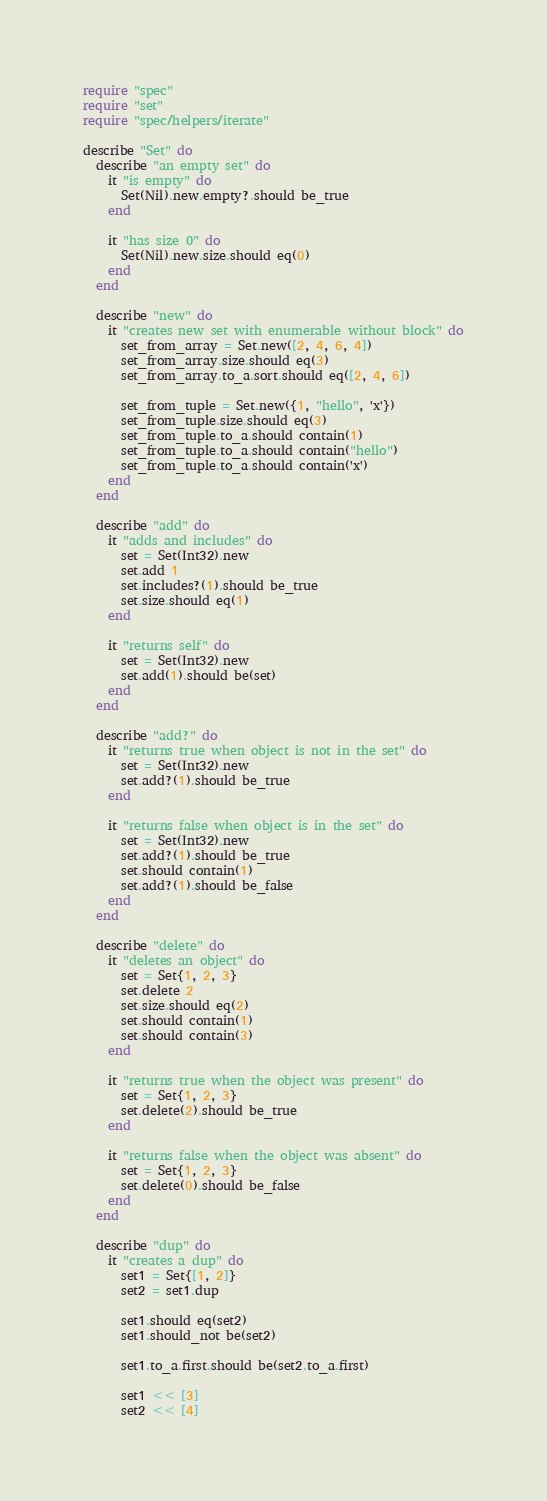Convert code to text. <code><loc_0><loc_0><loc_500><loc_500><_Crystal_>require "spec"
require "set"
require "spec/helpers/iterate"

describe "Set" do
  describe "an empty set" do
    it "is empty" do
      Set(Nil).new.empty?.should be_true
    end

    it "has size 0" do
      Set(Nil).new.size.should eq(0)
    end
  end

  describe "new" do
    it "creates new set with enumerable without block" do
      set_from_array = Set.new([2, 4, 6, 4])
      set_from_array.size.should eq(3)
      set_from_array.to_a.sort.should eq([2, 4, 6])

      set_from_tuple = Set.new({1, "hello", 'x'})
      set_from_tuple.size.should eq(3)
      set_from_tuple.to_a.should contain(1)
      set_from_tuple.to_a.should contain("hello")
      set_from_tuple.to_a.should contain('x')
    end
  end

  describe "add" do
    it "adds and includes" do
      set = Set(Int32).new
      set.add 1
      set.includes?(1).should be_true
      set.size.should eq(1)
    end

    it "returns self" do
      set = Set(Int32).new
      set.add(1).should be(set)
    end
  end

  describe "add?" do
    it "returns true when object is not in the set" do
      set = Set(Int32).new
      set.add?(1).should be_true
    end

    it "returns false when object is in the set" do
      set = Set(Int32).new
      set.add?(1).should be_true
      set.should contain(1)
      set.add?(1).should be_false
    end
  end

  describe "delete" do
    it "deletes an object" do
      set = Set{1, 2, 3}
      set.delete 2
      set.size.should eq(2)
      set.should contain(1)
      set.should contain(3)
    end

    it "returns true when the object was present" do
      set = Set{1, 2, 3}
      set.delete(2).should be_true
    end

    it "returns false when the object was absent" do
      set = Set{1, 2, 3}
      set.delete(0).should be_false
    end
  end

  describe "dup" do
    it "creates a dup" do
      set1 = Set{[1, 2]}
      set2 = set1.dup

      set1.should eq(set2)
      set1.should_not be(set2)

      set1.to_a.first.should be(set2.to_a.first)

      set1 << [3]
      set2 << [4]
</code> 